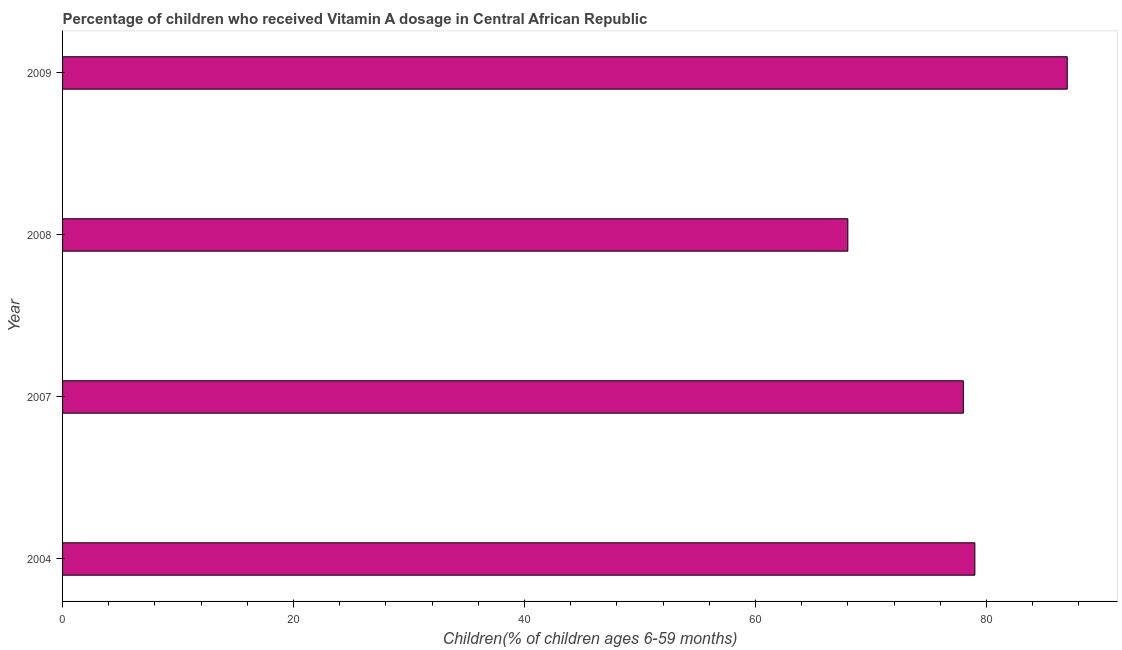Does the graph contain any zero values?
Your answer should be compact. No. What is the title of the graph?
Your answer should be very brief. Percentage of children who received Vitamin A dosage in Central African Republic. What is the label or title of the X-axis?
Keep it short and to the point. Children(% of children ages 6-59 months). What is the vitamin a supplementation coverage rate in 2004?
Offer a very short reply. 79. Across all years, what is the maximum vitamin a supplementation coverage rate?
Keep it short and to the point. 87. In which year was the vitamin a supplementation coverage rate maximum?
Your answer should be very brief. 2009. What is the sum of the vitamin a supplementation coverage rate?
Give a very brief answer. 312. What is the difference between the vitamin a supplementation coverage rate in 2007 and 2008?
Make the answer very short. 10. What is the median vitamin a supplementation coverage rate?
Your answer should be very brief. 78.5. In how many years, is the vitamin a supplementation coverage rate greater than 12 %?
Make the answer very short. 4. Do a majority of the years between 2009 and 2004 (inclusive) have vitamin a supplementation coverage rate greater than 76 %?
Provide a short and direct response. Yes. What is the ratio of the vitamin a supplementation coverage rate in 2004 to that in 2009?
Provide a succinct answer. 0.91. What is the difference between the highest and the second highest vitamin a supplementation coverage rate?
Offer a very short reply. 8. Is the sum of the vitamin a supplementation coverage rate in 2008 and 2009 greater than the maximum vitamin a supplementation coverage rate across all years?
Your response must be concise. Yes. In how many years, is the vitamin a supplementation coverage rate greater than the average vitamin a supplementation coverage rate taken over all years?
Your answer should be very brief. 2. What is the Children(% of children ages 6-59 months) of 2004?
Give a very brief answer. 79. What is the Children(% of children ages 6-59 months) in 2007?
Give a very brief answer. 78. What is the difference between the Children(% of children ages 6-59 months) in 2004 and 2009?
Your response must be concise. -8. What is the difference between the Children(% of children ages 6-59 months) in 2007 and 2009?
Make the answer very short. -9. What is the difference between the Children(% of children ages 6-59 months) in 2008 and 2009?
Ensure brevity in your answer.  -19. What is the ratio of the Children(% of children ages 6-59 months) in 2004 to that in 2007?
Keep it short and to the point. 1.01. What is the ratio of the Children(% of children ages 6-59 months) in 2004 to that in 2008?
Provide a succinct answer. 1.16. What is the ratio of the Children(% of children ages 6-59 months) in 2004 to that in 2009?
Give a very brief answer. 0.91. What is the ratio of the Children(% of children ages 6-59 months) in 2007 to that in 2008?
Provide a short and direct response. 1.15. What is the ratio of the Children(% of children ages 6-59 months) in 2007 to that in 2009?
Give a very brief answer. 0.9. What is the ratio of the Children(% of children ages 6-59 months) in 2008 to that in 2009?
Give a very brief answer. 0.78. 